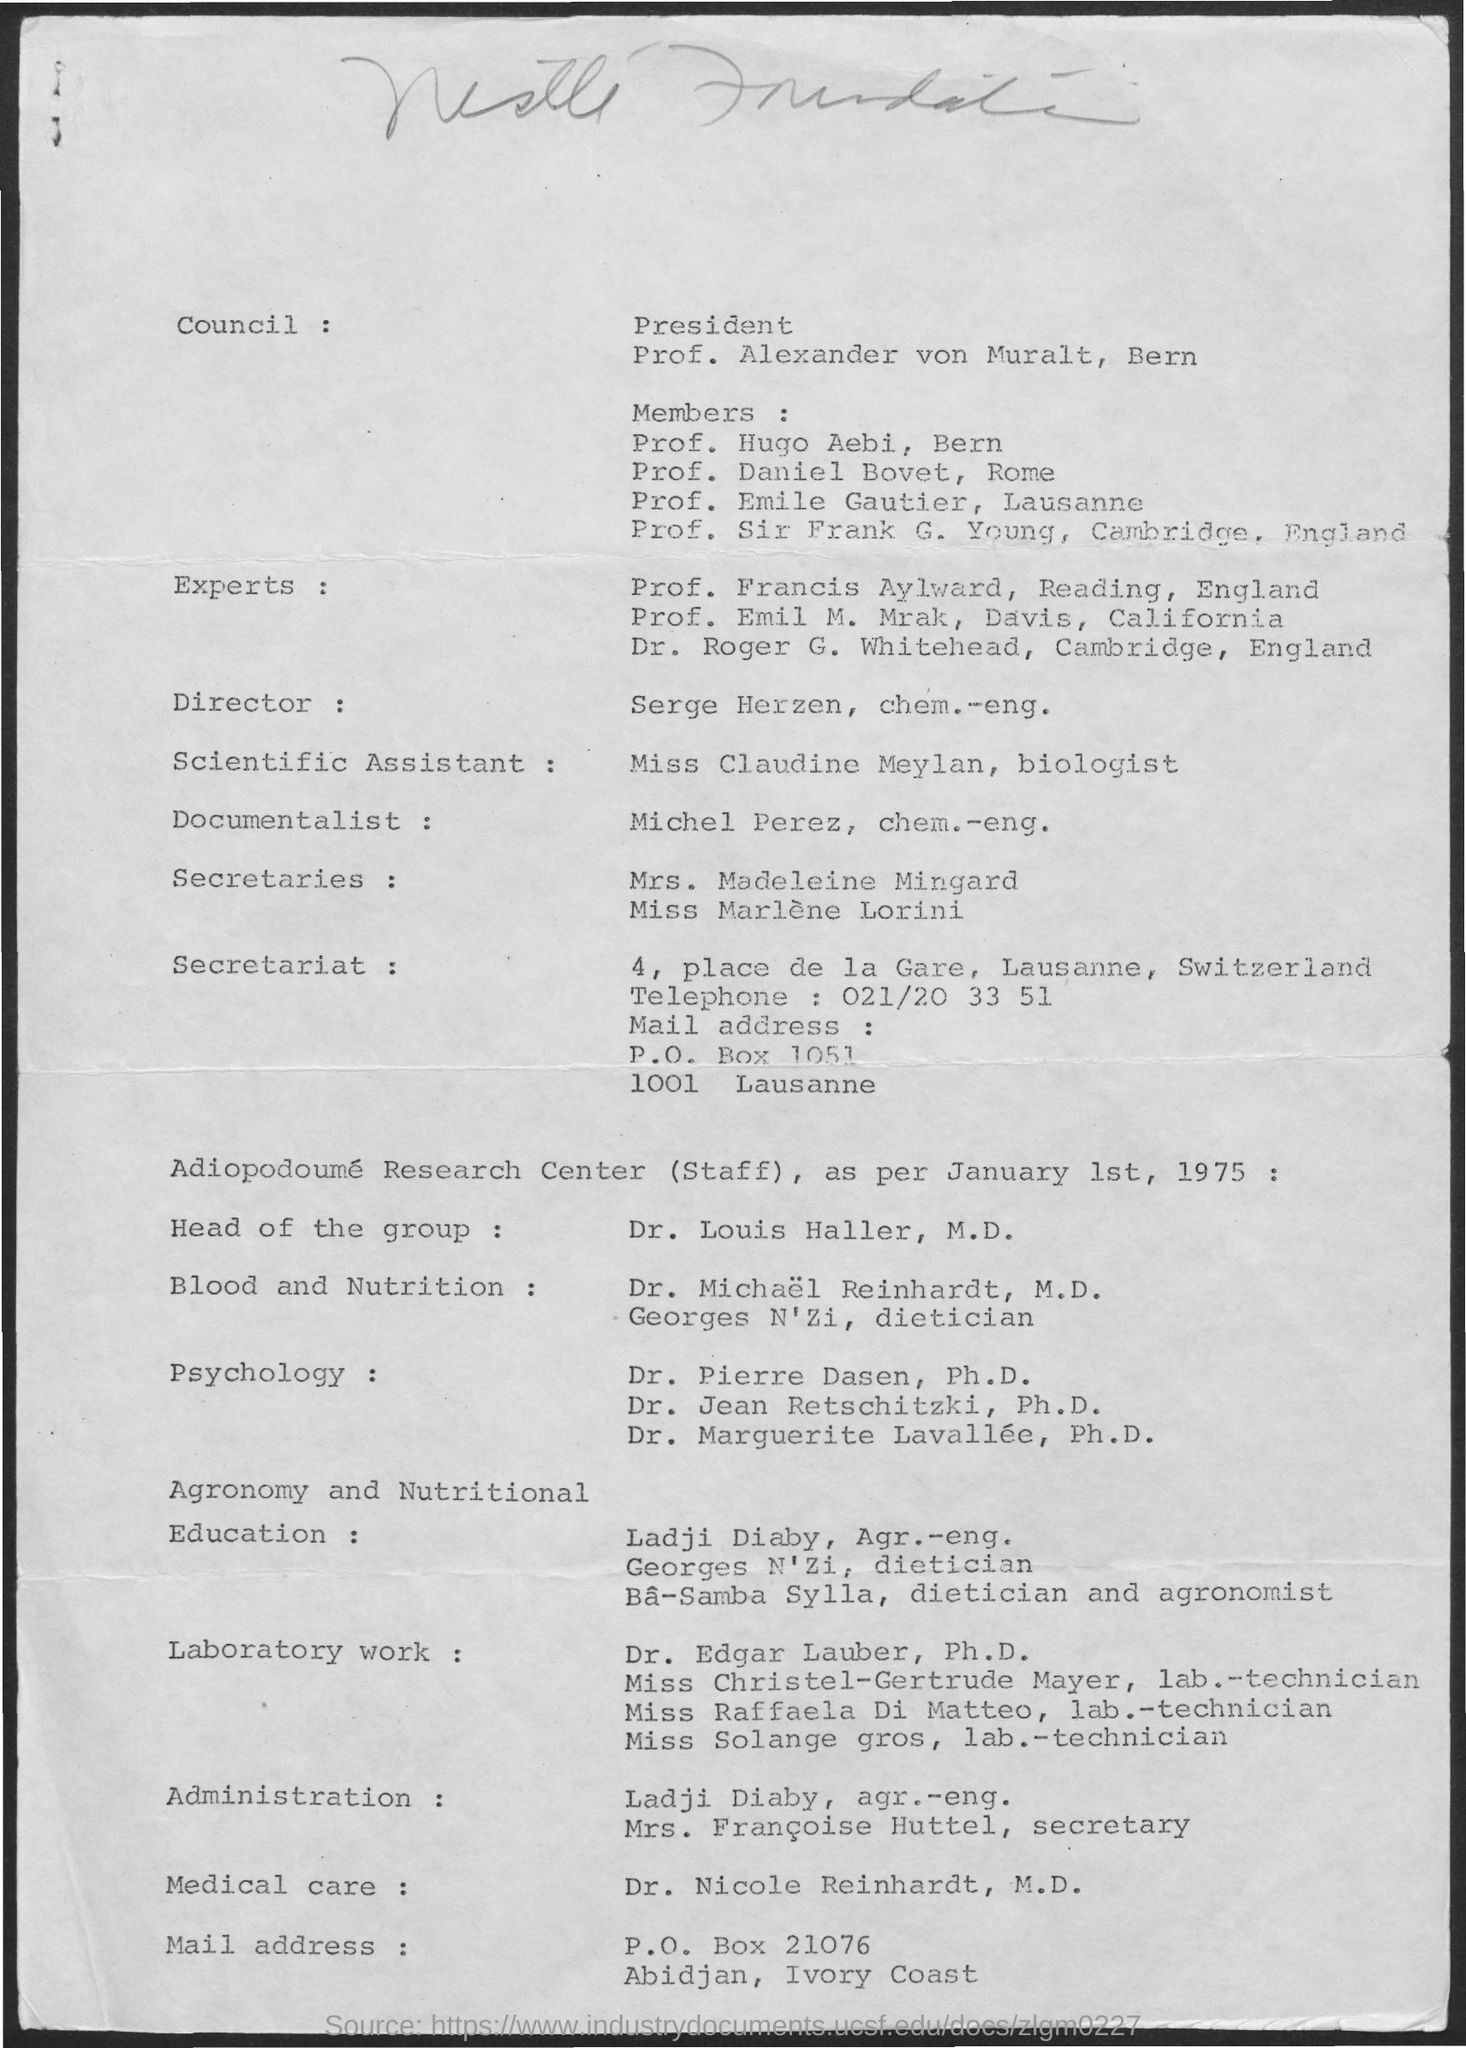Who is the Director?
Offer a very short reply. Serge Herzen. Who is the documentalist?
Give a very brief answer. Michel Perez. Cambridge is in which country?
Make the answer very short. England. What is the date mentioned in the document?
Offer a very short reply. January 1st, 1975. What is the telephone number of the secretariat?
Your answer should be compact. 021/20 33 51. 